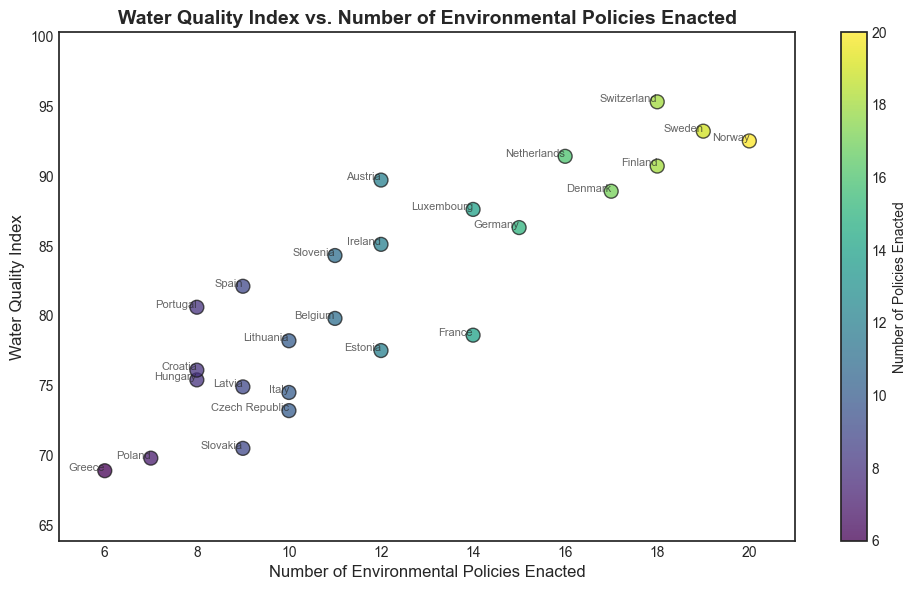What is the country with the highest Water Quality Index? The scatter plot shows different countries marked at various points. The country with the highest point on the vertical axis represents the highest Water Quality Index. Looking at the plot, this country is Switzerland.
Answer: Switzerland How many environmental policies did Germany enact, and what is its Water Quality Index? We look for the point labeled "Germany" on the scatter plot. From the plot, Germany enacted 15 environmental policies and has a Water Quality Index of 86.3.
Answer: 15, 86.3 Which country enacted fewer environmental policies, Italy or Ireland? We compare the horizontal positions of the points labeled "Italy" and "Ireland". Italy is positioned left of Ireland, indicating it enacted fewer policies (10 for Italy and 12 for Ireland).
Answer: Italy Which country has a higher Water Quality Index: Portugal or Croatia? We compare the vertical positions of the points labeled "Portugal" and "Croatia". Portugal (80.6) is lower on the vertical axis compared to Croatia (76.1), indicating Croatia has a higher Water Quality Index.
Answer: Portugal Is there a general trend between the number of environmental policies enacted and the Water Quality Index? By observing the scatter plot's spread, we notice that countries with more environmental policies enacted tend to have a higher Water Quality Index; hence, a positive correlation exists.
Answer: Positive correlation What is the average Water Quality Index of countries that enacted 10 environmental policies? We look at the points where the horizontal axis value equals 10 and find the corresponding Water Quality Indices: Italy (74.5), Czech Republic (73.2), and Lithuania (78.2). The average is calculated as: (74.5 + 73.2 + 78.2) / 3 = 75.3
Answer: 75.3 Which country enacted 16 environmental policies, and what is its Water Quality Index? We look for the point on the scatter plot where the horizontal axis value is 16. The corresponding country is the Netherlands, with a Water Quality Index of 91.4.
Answer: Netherlands Are there any countries that have enacted fewer than 10 policies but have a Water Quality Index above 80? We find the points left of '10' on the horizontal axis and check if their vertical axis is above 80. Spain is the only country meeting this criterion, with 9 policies and an index of 82.1.
Answer: Spain Which country has the lowest Water Quality Index, and how many policies did it enact? The point lowest on the vertical axis represents the lowest Water Quality Index. This country is Greece with an index of 68.9, and it enacted 6 policies.
Answer: Greece 